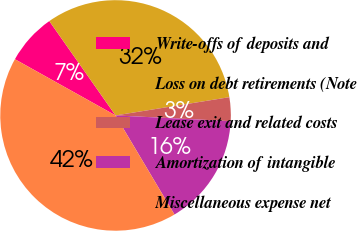<chart> <loc_0><loc_0><loc_500><loc_500><pie_chart><fcel>Write-offs of deposits and<fcel>Loss on debt retirements (Note<fcel>Lease exit and related costs<fcel>Amortization of intangible<fcel>Miscellaneous expense net<nl><fcel>7.15%<fcel>32.21%<fcel>3.32%<fcel>15.67%<fcel>41.65%<nl></chart> 